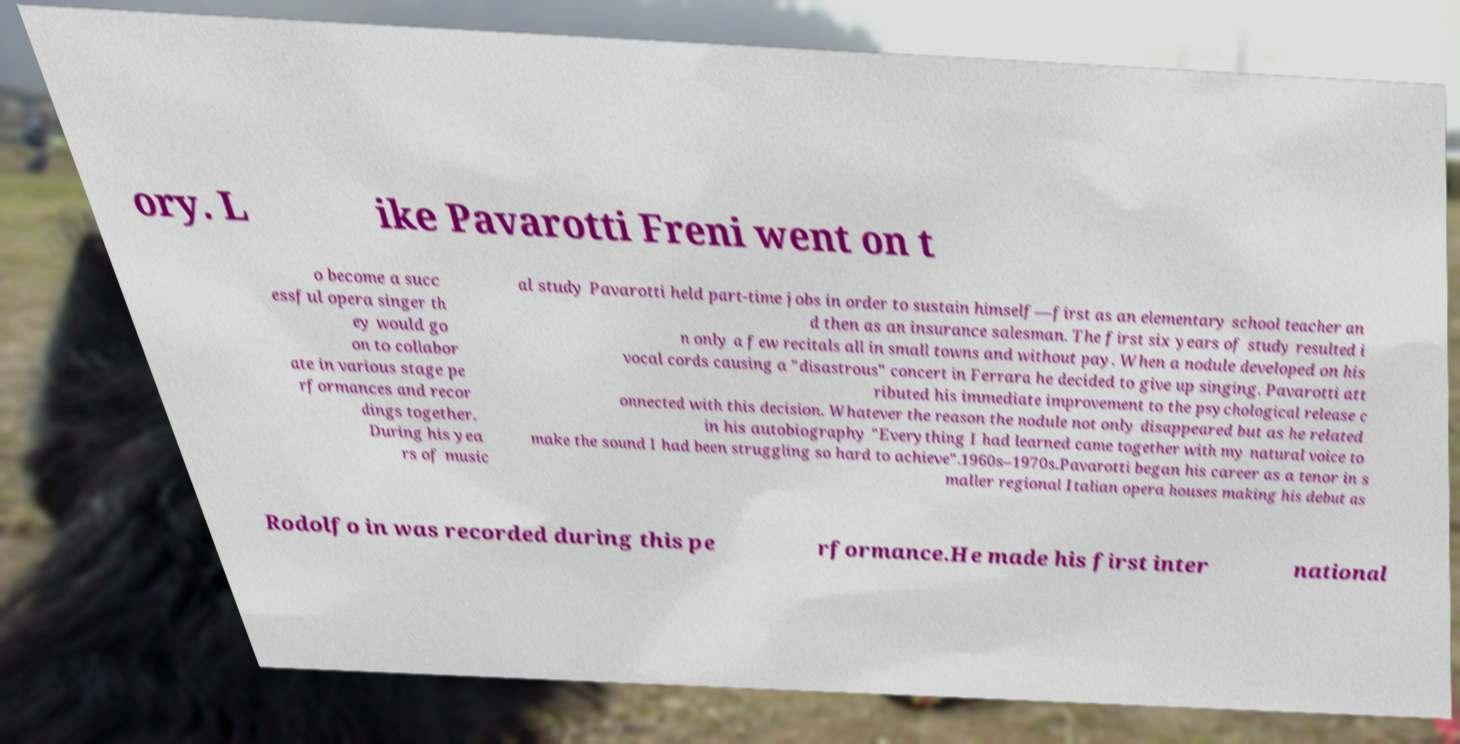Please read and relay the text visible in this image. What does it say? ory. L ike Pavarotti Freni went on t o become a succ essful opera singer th ey would go on to collabor ate in various stage pe rformances and recor dings together. During his yea rs of music al study Pavarotti held part-time jobs in order to sustain himself—first as an elementary school teacher an d then as an insurance salesman. The first six years of study resulted i n only a few recitals all in small towns and without pay. When a nodule developed on his vocal cords causing a "disastrous" concert in Ferrara he decided to give up singing. Pavarotti att ributed his immediate improvement to the psychological release c onnected with this decision. Whatever the reason the nodule not only disappeared but as he related in his autobiography "Everything I had learned came together with my natural voice to make the sound I had been struggling so hard to achieve".1960s–1970s.Pavarotti began his career as a tenor in s maller regional Italian opera houses making his debut as Rodolfo in was recorded during this pe rformance.He made his first inter national 